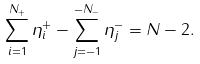Convert formula to latex. <formula><loc_0><loc_0><loc_500><loc_500>\sum _ { i = 1 } ^ { N _ { + } } \eta _ { i } ^ { + } - \sum _ { j = - 1 } ^ { - N _ { - } } \eta _ { j } ^ { - } = N - 2 .</formula> 